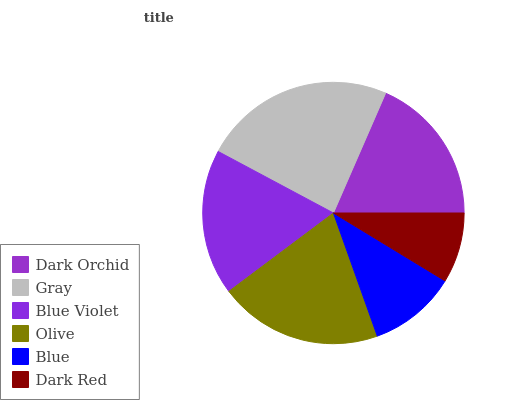Is Dark Red the minimum?
Answer yes or no. Yes. Is Gray the maximum?
Answer yes or no. Yes. Is Blue Violet the minimum?
Answer yes or no. No. Is Blue Violet the maximum?
Answer yes or no. No. Is Gray greater than Blue Violet?
Answer yes or no. Yes. Is Blue Violet less than Gray?
Answer yes or no. Yes. Is Blue Violet greater than Gray?
Answer yes or no. No. Is Gray less than Blue Violet?
Answer yes or no. No. Is Dark Orchid the high median?
Answer yes or no. Yes. Is Blue Violet the low median?
Answer yes or no. Yes. Is Gray the high median?
Answer yes or no. No. Is Dark Orchid the low median?
Answer yes or no. No. 